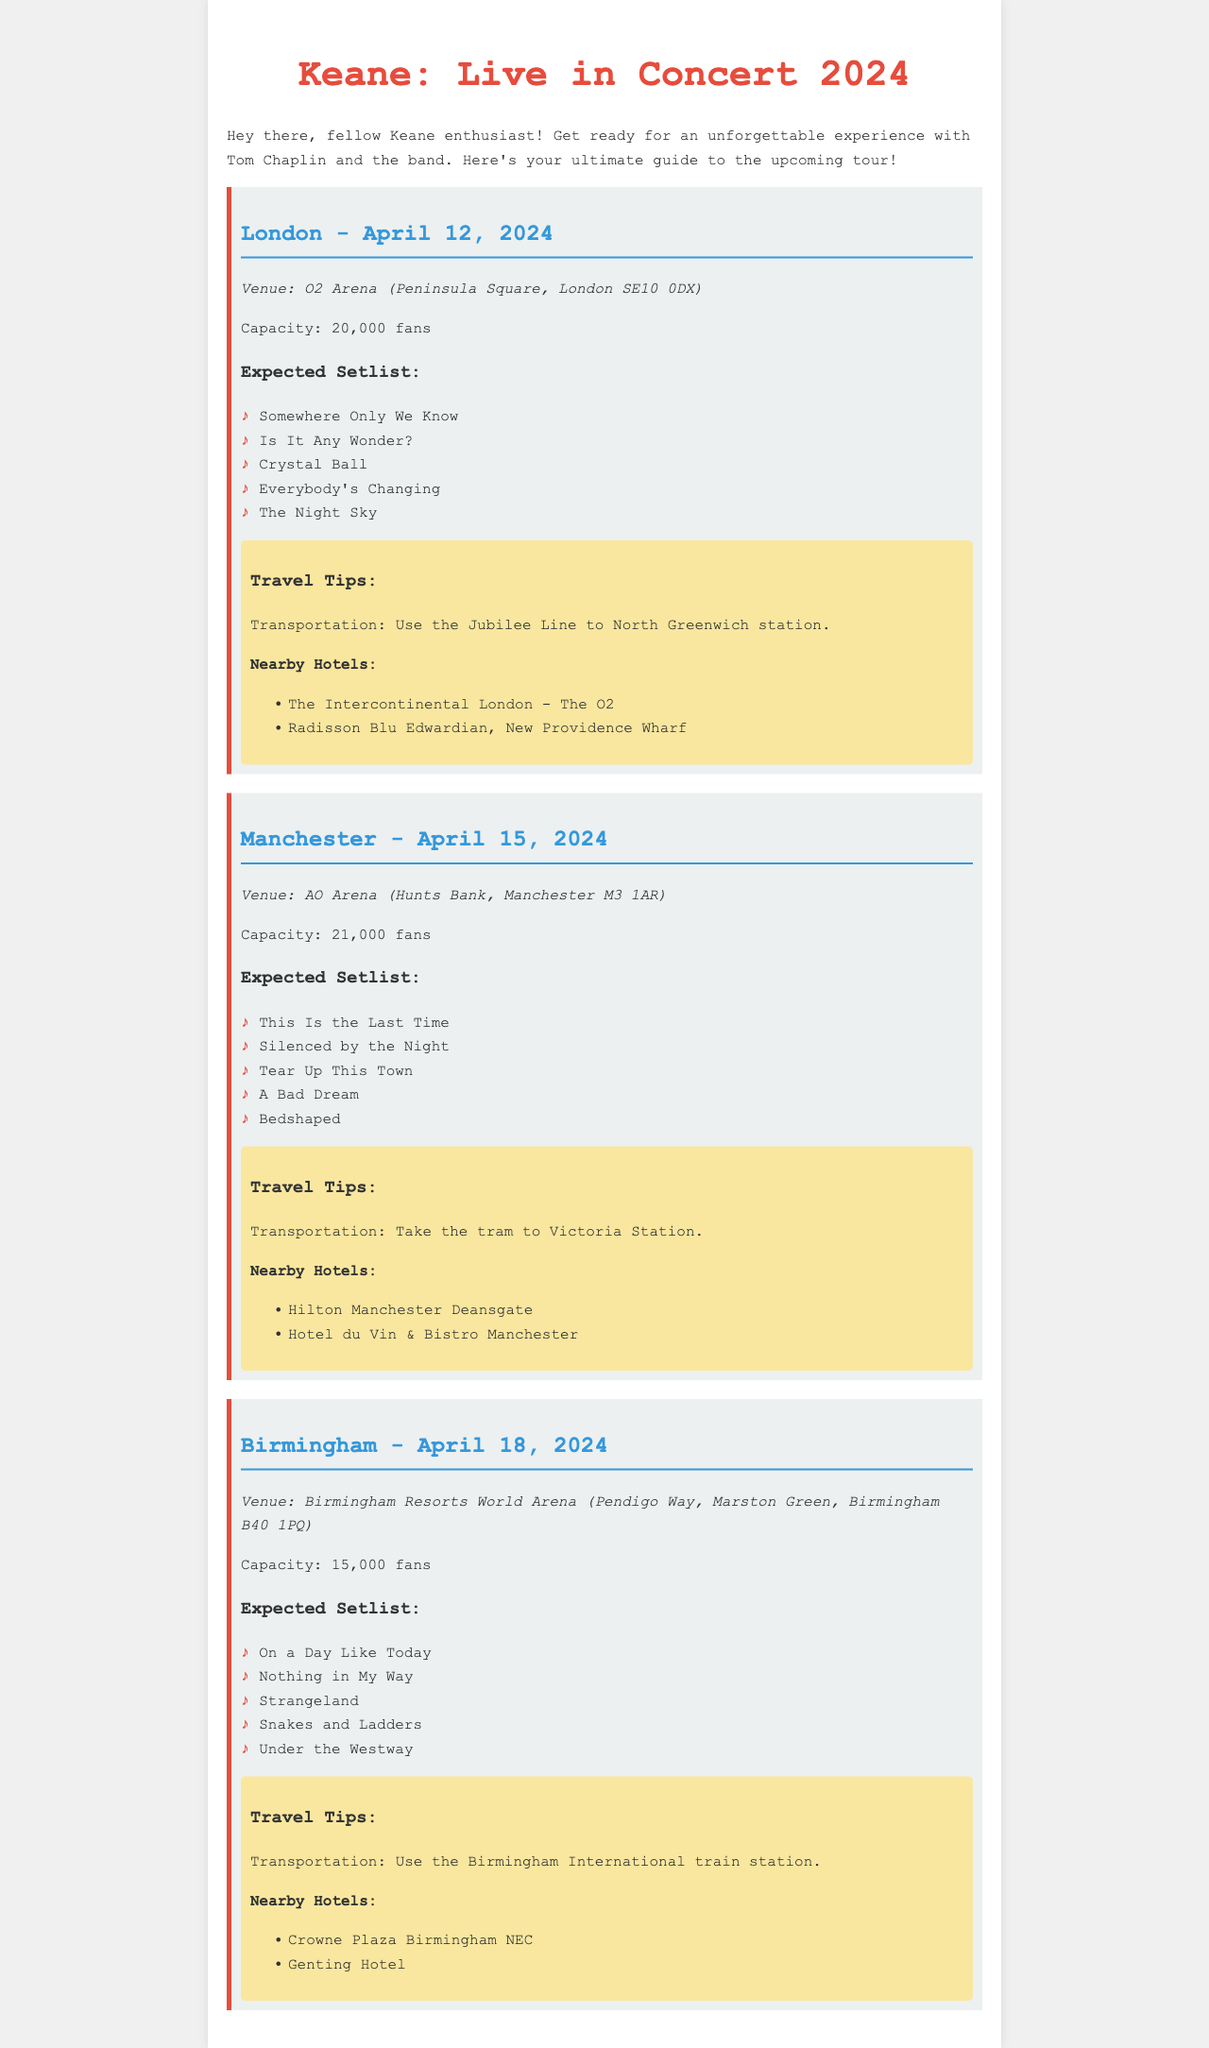What is the date of the concert in London? The concert in London is scheduled for April 12, 2024.
Answer: April 12, 2024 What is the venue for the Manchester concert? The venue for the Manchester concert is AO Arena.
Answer: AO Arena How many fans can the Birmingham venue accommodate? The Birmingham Resorts World Arena has a capacity of 15,000 fans.
Answer: 15,000 fans What song is expected to be played in Birmingham? One of the expected songs to be played in Birmingham is "On a Day Like Today."
Answer: On a Day Like Today Which hotel is located near the London concert venue? The Intercontinental London - The O2 is a hotel near the London concert venue.
Answer: The Intercontinental London - The O2 What transportation should be used to reach the Birmingham venue? You should use the Birmingham International train station to reach the Birmingham venue.
Answer: Birmingham International train station Which concert has a larger venue capacity, London or Manchester? The Manchester concert has a larger venue capacity of 21,000 fans compared to London's 20,000.
Answer: Manchester How many expected songs are listed for the London concert? There are five expected songs listed for the London concert.
Answer: Five What is a recommended mode of transportation for the Manchester concert? The recommended mode of transportation for the Manchester concert is the tram.
Answer: Tram 